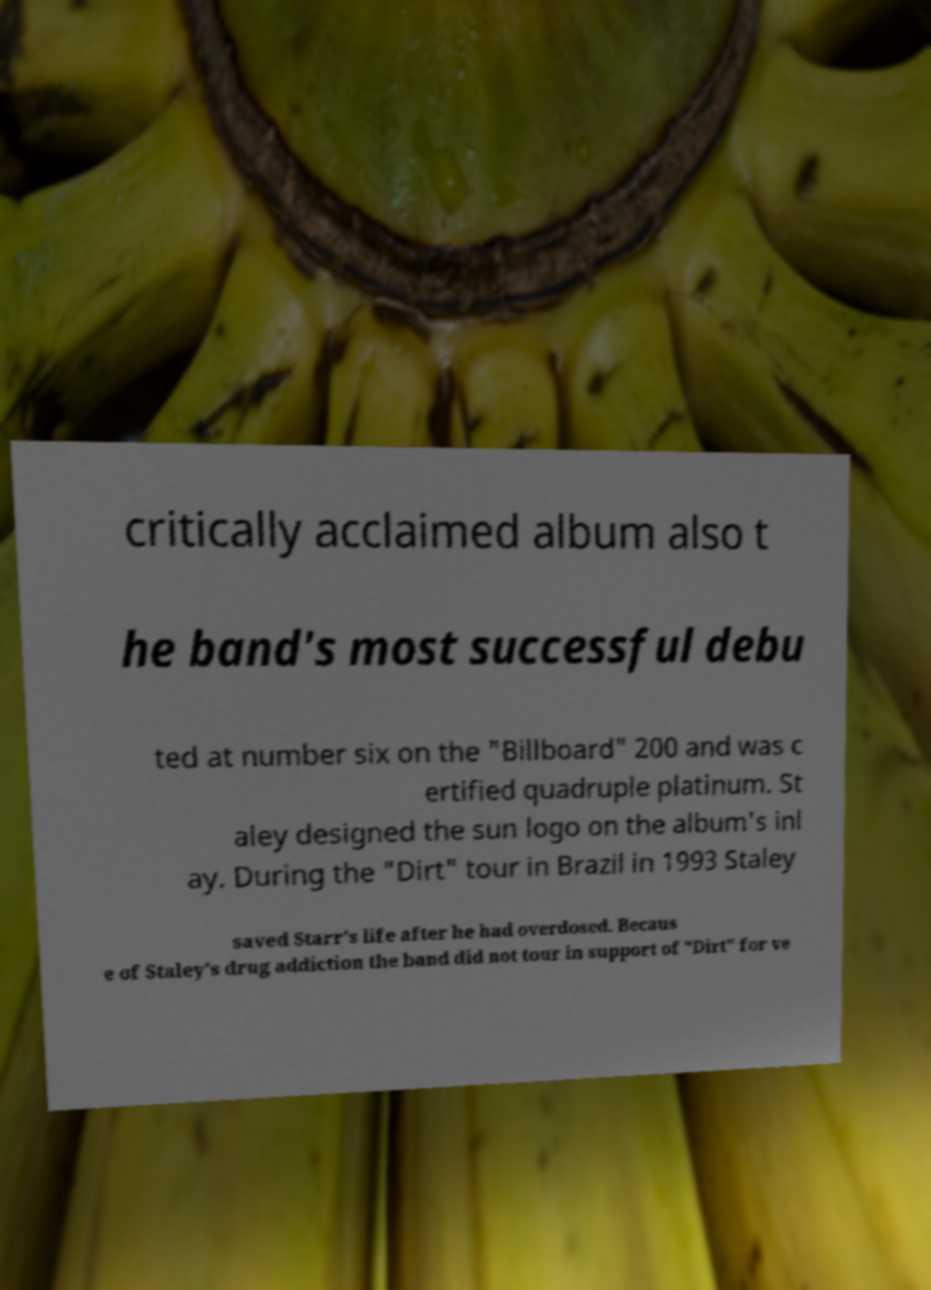What messages or text are displayed in this image? I need them in a readable, typed format. critically acclaimed album also t he band's most successful debu ted at number six on the "Billboard" 200 and was c ertified quadruple platinum. St aley designed the sun logo on the album's inl ay. During the "Dirt" tour in Brazil in 1993 Staley saved Starr's life after he had overdosed. Becaus e of Staley's drug addiction the band did not tour in support of "Dirt" for ve 